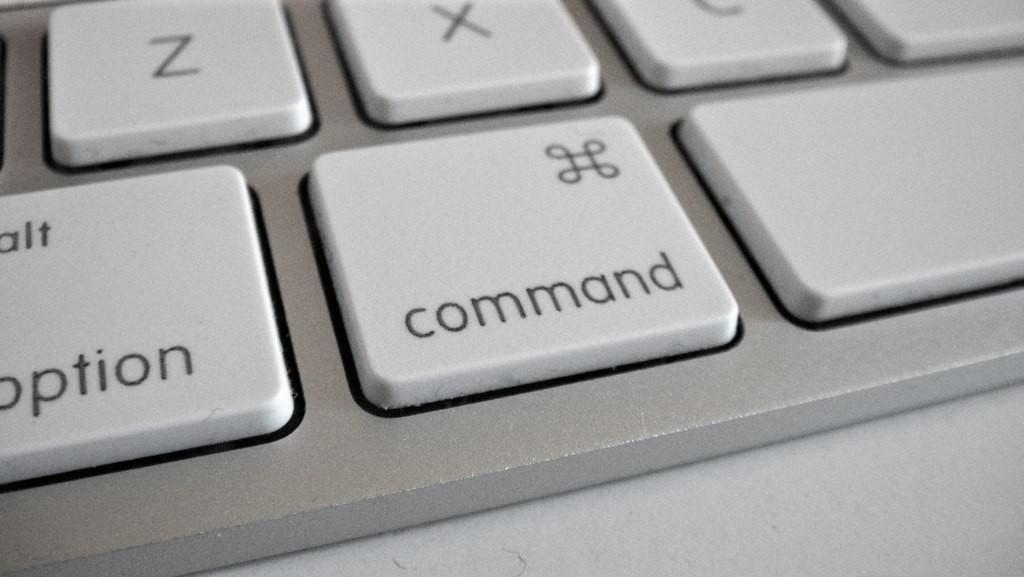What is written on the key in the middle of the picture?
Give a very brief answer. Command. What is written on the front left key?
Ensure brevity in your answer.  Option. 